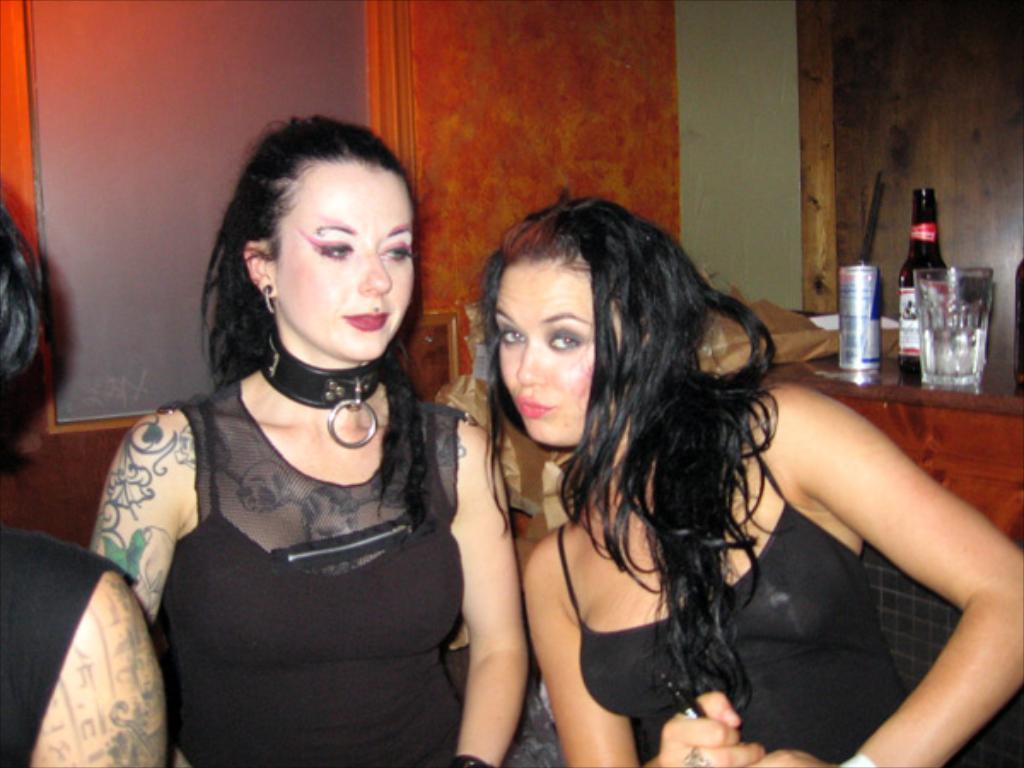How would you summarize this image in a sentence or two? In this picture we can see three persons were two women are smiling and in the background we can see a bottle, tin, glass, wall. 